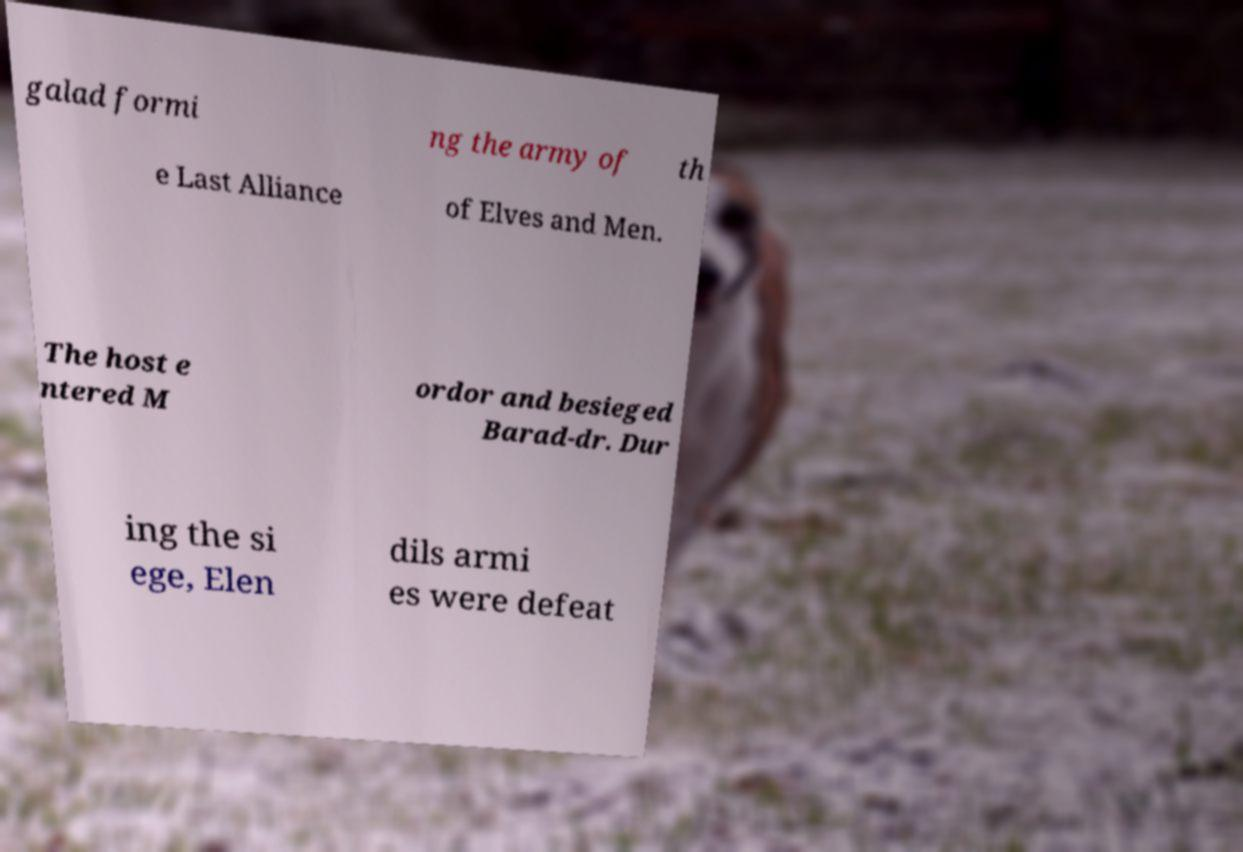Could you extract and type out the text from this image? galad formi ng the army of th e Last Alliance of Elves and Men. The host e ntered M ordor and besieged Barad-dr. Dur ing the si ege, Elen dils armi es were defeat 